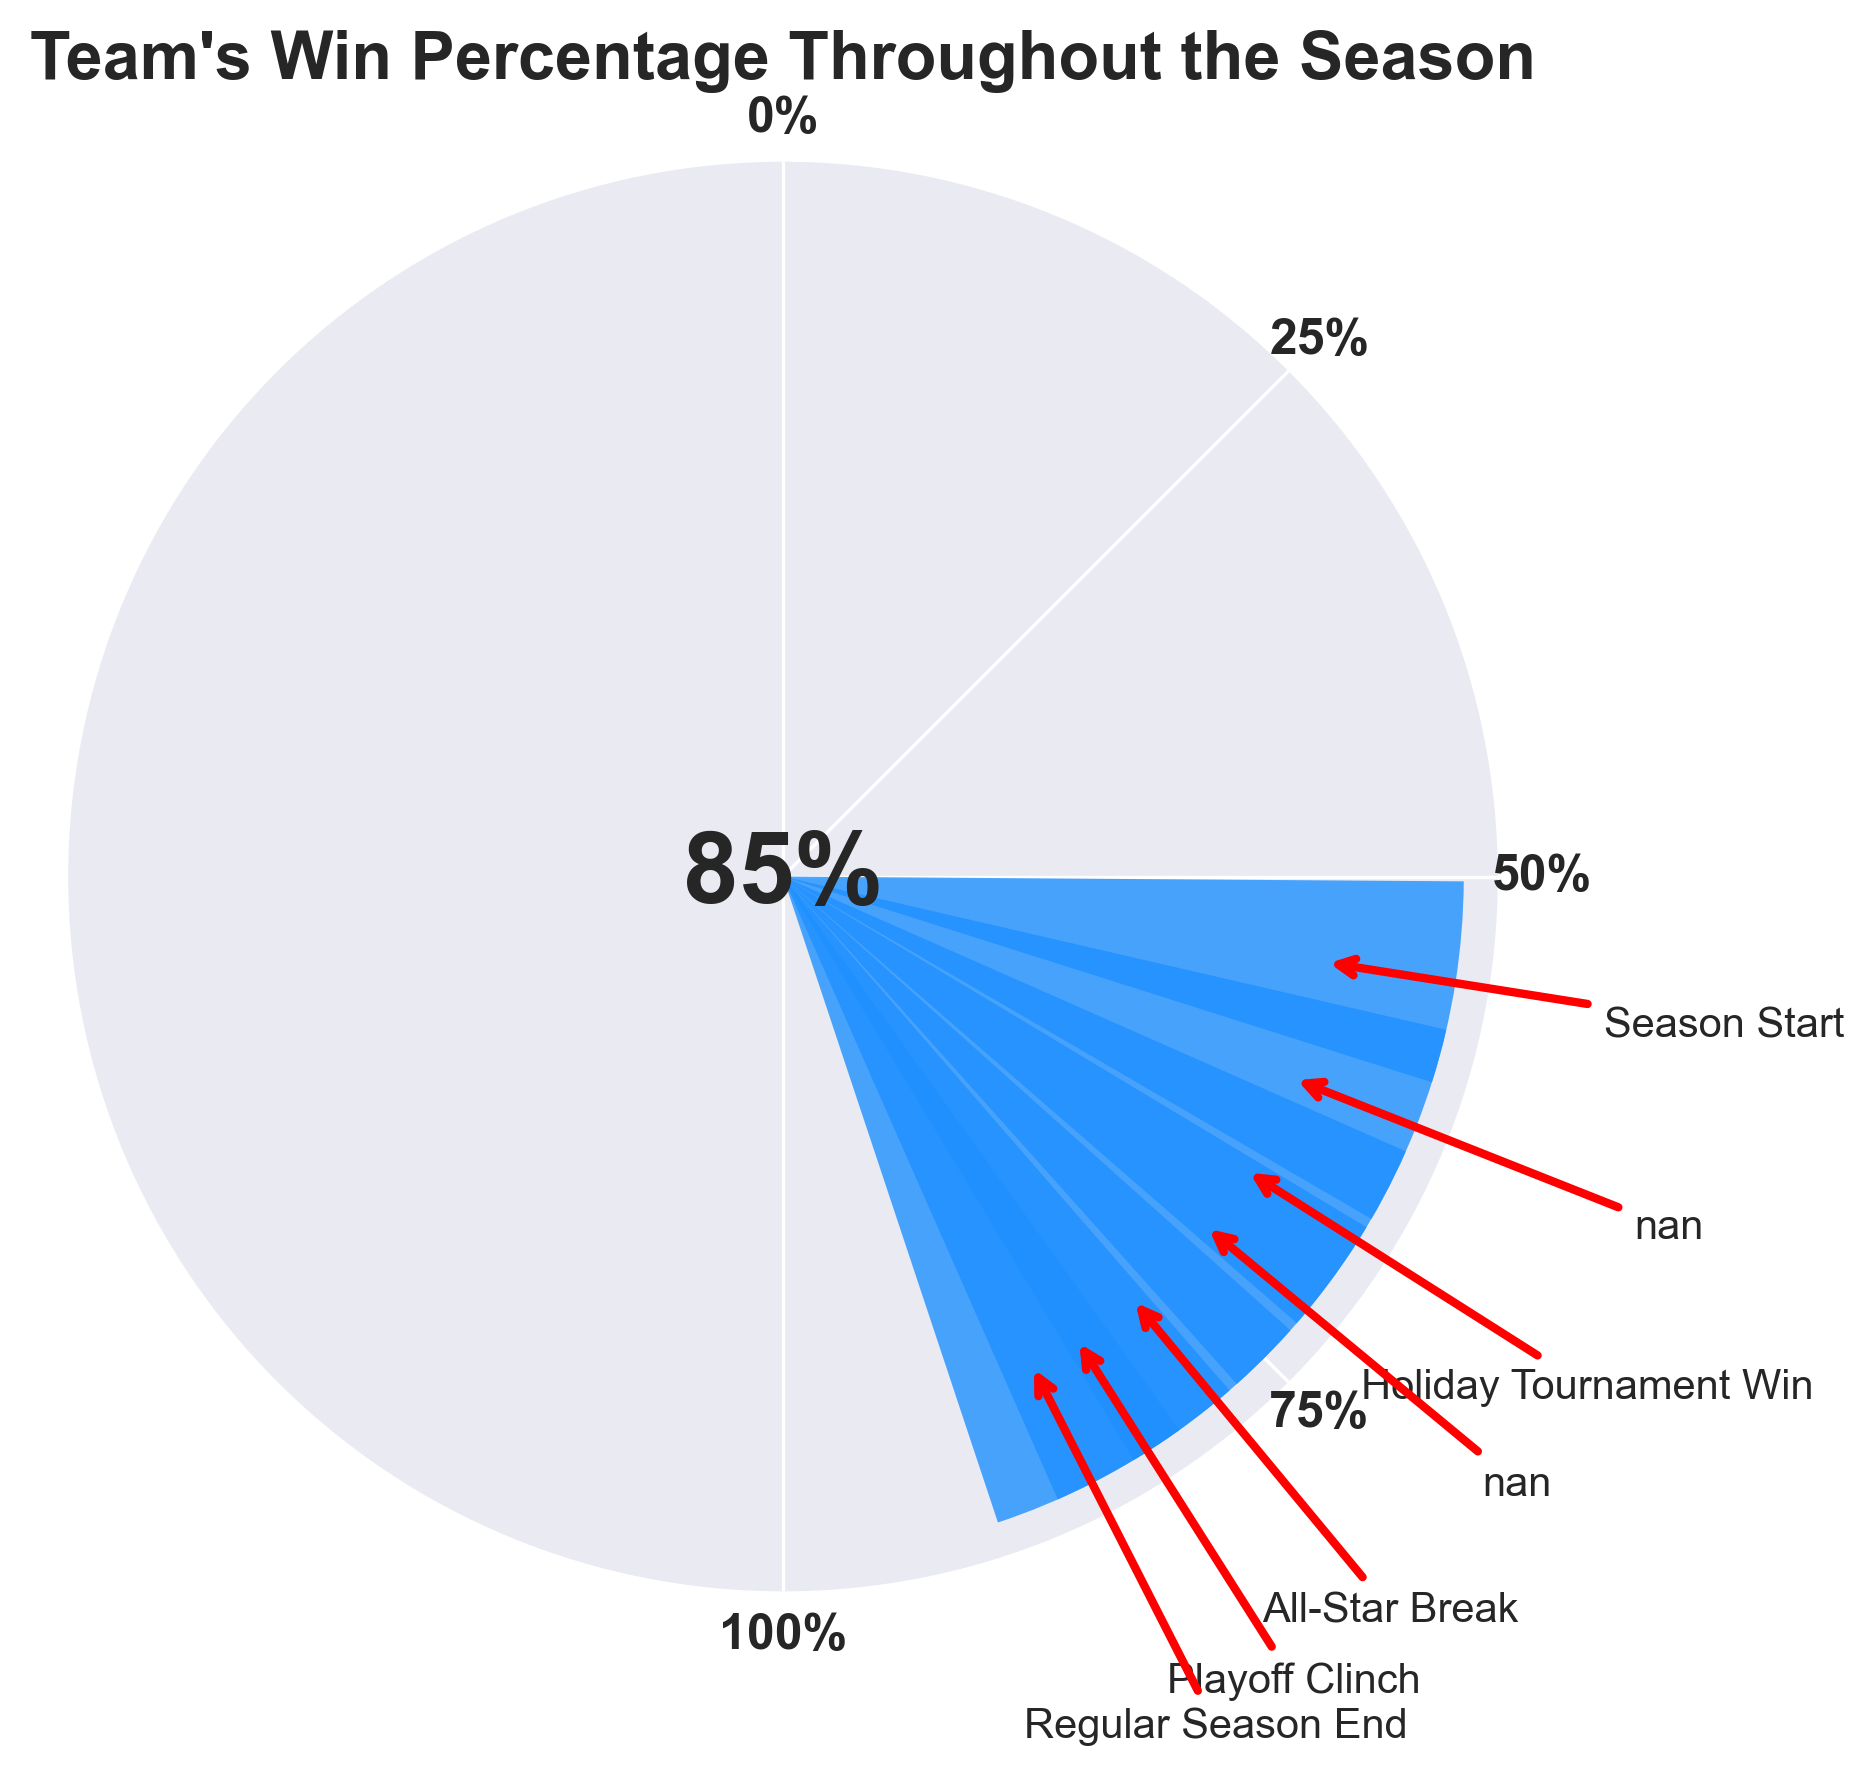What is the title of the figure? The title is displayed at the top of the figure.
Answer: Team's Win Percentage Throughout the Season Which month shows the highest win percentage? By looking at the endpoint of the gauge, where the highest percentage is marked, we see April.
Answer: April What is the team's win percentage during the All-Star Break? Locate February on the gauge, which is annotated as the All-Star Break.
Answer: 78% How many milestones are highlighted in the chart? Count the number of annotated arrows on the figure.
Answer: 4 What was the win percentage at the starting point of the season? Look at the milestone labeled 'Season Start' on the gauge, which corresponds to October.
Answer: 55% Which milestone occurred in March, and what was the win percentage? Identify March on the gauge; it’s annotated with 'Playoff Clinch'.
Answer: Playoff Clinch, 82% What is the average win percentage increase from October to April? Calculate the increase from October (55%) to April (85%), which is 85 - 55 = 30. Then divide by the number of intervals (6).
Answer: 5% Between which two consecutive months did the win percentage increase the most? Compare the differences between consecutive months: November-October (7%), December-November (6%), January-December (4%), February-January (6%), March-February (4%), April-March (3%).
Answer: November-October How does the win percentage trend throughout the season? From the sequence of increasing win percentages on the gauge, it shows a consistent upward trend increasing each month.
Answer: Upward trend What percentage does the gauge show for December? Find the point labeled December on the gauge.
Answer: 68% 